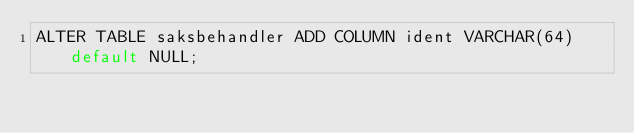<code> <loc_0><loc_0><loc_500><loc_500><_SQL_>ALTER TABLE saksbehandler ADD COLUMN ident VARCHAR(64) default NULL;
</code> 